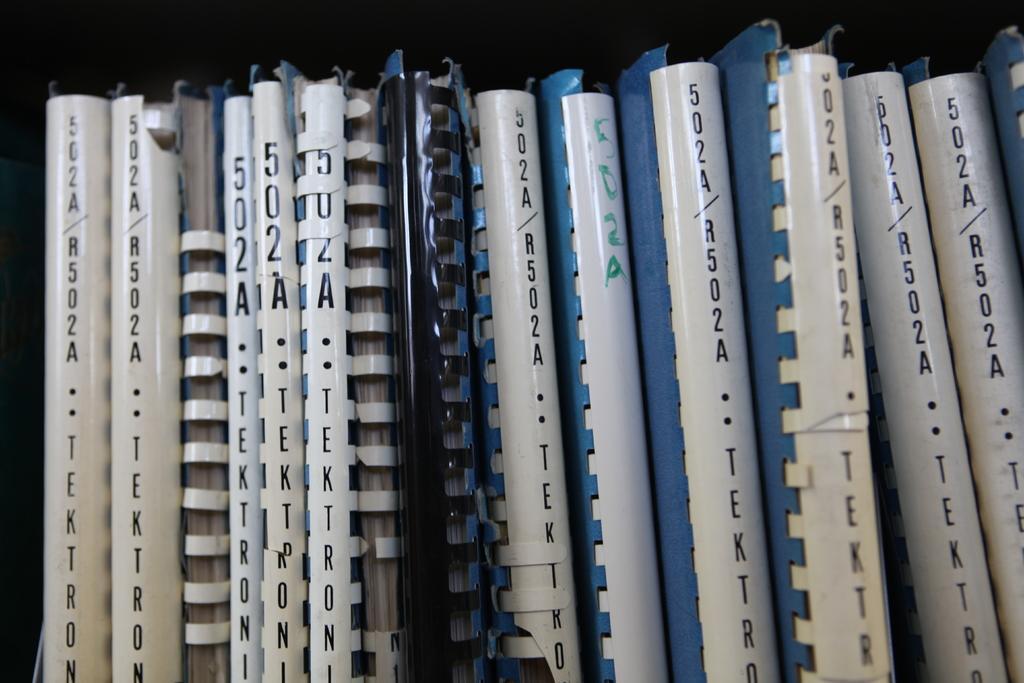Please provide a concise description of this image. In this image I can see few objects which are in black, white, blue and cream color. I can see there is a black background. 